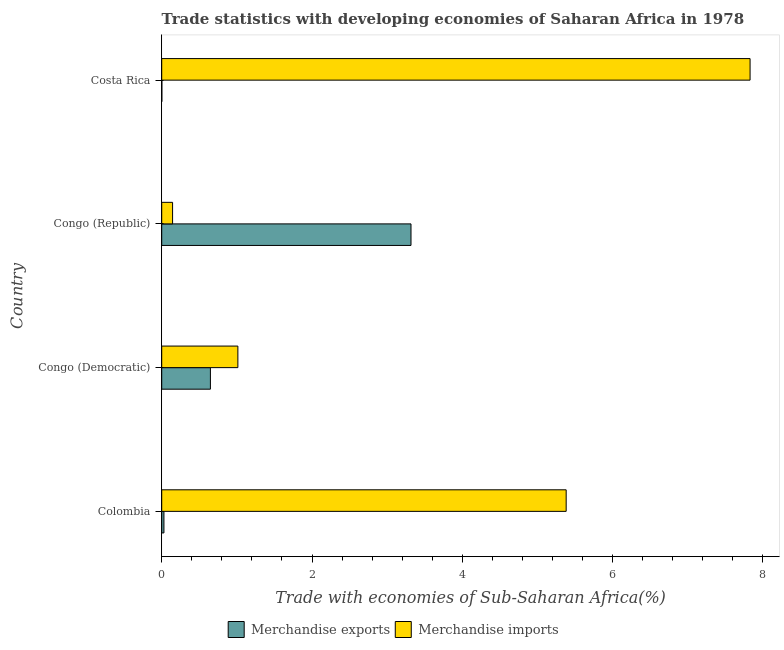How many different coloured bars are there?
Your response must be concise. 2. How many groups of bars are there?
Ensure brevity in your answer.  4. Are the number of bars per tick equal to the number of legend labels?
Your answer should be very brief. Yes. Are the number of bars on each tick of the Y-axis equal?
Keep it short and to the point. Yes. How many bars are there on the 2nd tick from the top?
Keep it short and to the point. 2. How many bars are there on the 4th tick from the bottom?
Your response must be concise. 2. What is the label of the 3rd group of bars from the top?
Give a very brief answer. Congo (Democratic). In how many cases, is the number of bars for a given country not equal to the number of legend labels?
Give a very brief answer. 0. What is the merchandise imports in Congo (Republic)?
Keep it short and to the point. 0.14. Across all countries, what is the maximum merchandise imports?
Keep it short and to the point. 7.83. Across all countries, what is the minimum merchandise imports?
Provide a succinct answer. 0.14. In which country was the merchandise exports maximum?
Keep it short and to the point. Congo (Republic). What is the total merchandise imports in the graph?
Offer a terse response. 14.37. What is the difference between the merchandise imports in Colombia and that in Costa Rica?
Provide a succinct answer. -2.45. What is the difference between the merchandise imports in Costa Rica and the merchandise exports in Congo (Republic)?
Your answer should be very brief. 4.51. What is the average merchandise imports per country?
Keep it short and to the point. 3.59. What is the difference between the merchandise imports and merchandise exports in Congo (Democratic)?
Provide a succinct answer. 0.37. In how many countries, is the merchandise exports greater than 2 %?
Provide a short and direct response. 1. What is the ratio of the merchandise exports in Congo (Democratic) to that in Congo (Republic)?
Offer a very short reply. 0.2. Is the merchandise exports in Congo (Democratic) less than that in Costa Rica?
Ensure brevity in your answer.  No. Is the difference between the merchandise exports in Congo (Democratic) and Congo (Republic) greater than the difference between the merchandise imports in Congo (Democratic) and Congo (Republic)?
Ensure brevity in your answer.  No. What is the difference between the highest and the second highest merchandise imports?
Your answer should be very brief. 2.45. What is the difference between the highest and the lowest merchandise exports?
Ensure brevity in your answer.  3.32. How many countries are there in the graph?
Give a very brief answer. 4. Are the values on the major ticks of X-axis written in scientific E-notation?
Your response must be concise. No. Where does the legend appear in the graph?
Offer a terse response. Bottom center. How many legend labels are there?
Keep it short and to the point. 2. How are the legend labels stacked?
Provide a short and direct response. Horizontal. What is the title of the graph?
Keep it short and to the point. Trade statistics with developing economies of Saharan Africa in 1978. Does "Non-residents" appear as one of the legend labels in the graph?
Your response must be concise. No. What is the label or title of the X-axis?
Ensure brevity in your answer.  Trade with economies of Sub-Saharan Africa(%). What is the label or title of the Y-axis?
Your response must be concise. Country. What is the Trade with economies of Sub-Saharan Africa(%) in Merchandise exports in Colombia?
Give a very brief answer. 0.03. What is the Trade with economies of Sub-Saharan Africa(%) of Merchandise imports in Colombia?
Make the answer very short. 5.38. What is the Trade with economies of Sub-Saharan Africa(%) of Merchandise exports in Congo (Democratic)?
Your answer should be very brief. 0.65. What is the Trade with economies of Sub-Saharan Africa(%) in Merchandise imports in Congo (Democratic)?
Provide a short and direct response. 1.01. What is the Trade with economies of Sub-Saharan Africa(%) of Merchandise exports in Congo (Republic)?
Provide a succinct answer. 3.32. What is the Trade with economies of Sub-Saharan Africa(%) of Merchandise imports in Congo (Republic)?
Make the answer very short. 0.14. What is the Trade with economies of Sub-Saharan Africa(%) of Merchandise exports in Costa Rica?
Provide a short and direct response. 0. What is the Trade with economies of Sub-Saharan Africa(%) in Merchandise imports in Costa Rica?
Give a very brief answer. 7.83. Across all countries, what is the maximum Trade with economies of Sub-Saharan Africa(%) in Merchandise exports?
Your answer should be very brief. 3.32. Across all countries, what is the maximum Trade with economies of Sub-Saharan Africa(%) of Merchandise imports?
Your response must be concise. 7.83. Across all countries, what is the minimum Trade with economies of Sub-Saharan Africa(%) of Merchandise exports?
Keep it short and to the point. 0. Across all countries, what is the minimum Trade with economies of Sub-Saharan Africa(%) of Merchandise imports?
Ensure brevity in your answer.  0.14. What is the total Trade with economies of Sub-Saharan Africa(%) of Merchandise exports in the graph?
Offer a very short reply. 4. What is the total Trade with economies of Sub-Saharan Africa(%) of Merchandise imports in the graph?
Your answer should be very brief. 14.37. What is the difference between the Trade with economies of Sub-Saharan Africa(%) of Merchandise exports in Colombia and that in Congo (Democratic)?
Keep it short and to the point. -0.62. What is the difference between the Trade with economies of Sub-Saharan Africa(%) of Merchandise imports in Colombia and that in Congo (Democratic)?
Offer a very short reply. 4.37. What is the difference between the Trade with economies of Sub-Saharan Africa(%) in Merchandise exports in Colombia and that in Congo (Republic)?
Your response must be concise. -3.29. What is the difference between the Trade with economies of Sub-Saharan Africa(%) of Merchandise imports in Colombia and that in Congo (Republic)?
Offer a terse response. 5.24. What is the difference between the Trade with economies of Sub-Saharan Africa(%) in Merchandise exports in Colombia and that in Costa Rica?
Ensure brevity in your answer.  0.03. What is the difference between the Trade with economies of Sub-Saharan Africa(%) of Merchandise imports in Colombia and that in Costa Rica?
Offer a very short reply. -2.45. What is the difference between the Trade with economies of Sub-Saharan Africa(%) of Merchandise exports in Congo (Democratic) and that in Congo (Republic)?
Provide a succinct answer. -2.67. What is the difference between the Trade with economies of Sub-Saharan Africa(%) in Merchandise imports in Congo (Democratic) and that in Congo (Republic)?
Provide a succinct answer. 0.87. What is the difference between the Trade with economies of Sub-Saharan Africa(%) in Merchandise exports in Congo (Democratic) and that in Costa Rica?
Keep it short and to the point. 0.65. What is the difference between the Trade with economies of Sub-Saharan Africa(%) in Merchandise imports in Congo (Democratic) and that in Costa Rica?
Keep it short and to the point. -6.82. What is the difference between the Trade with economies of Sub-Saharan Africa(%) in Merchandise exports in Congo (Republic) and that in Costa Rica?
Make the answer very short. 3.32. What is the difference between the Trade with economies of Sub-Saharan Africa(%) of Merchandise imports in Congo (Republic) and that in Costa Rica?
Make the answer very short. -7.68. What is the difference between the Trade with economies of Sub-Saharan Africa(%) of Merchandise exports in Colombia and the Trade with economies of Sub-Saharan Africa(%) of Merchandise imports in Congo (Democratic)?
Your response must be concise. -0.98. What is the difference between the Trade with economies of Sub-Saharan Africa(%) in Merchandise exports in Colombia and the Trade with economies of Sub-Saharan Africa(%) in Merchandise imports in Congo (Republic)?
Your answer should be very brief. -0.11. What is the difference between the Trade with economies of Sub-Saharan Africa(%) of Merchandise exports in Colombia and the Trade with economies of Sub-Saharan Africa(%) of Merchandise imports in Costa Rica?
Ensure brevity in your answer.  -7.8. What is the difference between the Trade with economies of Sub-Saharan Africa(%) in Merchandise exports in Congo (Democratic) and the Trade with economies of Sub-Saharan Africa(%) in Merchandise imports in Congo (Republic)?
Your response must be concise. 0.5. What is the difference between the Trade with economies of Sub-Saharan Africa(%) in Merchandise exports in Congo (Democratic) and the Trade with economies of Sub-Saharan Africa(%) in Merchandise imports in Costa Rica?
Make the answer very short. -7.18. What is the difference between the Trade with economies of Sub-Saharan Africa(%) of Merchandise exports in Congo (Republic) and the Trade with economies of Sub-Saharan Africa(%) of Merchandise imports in Costa Rica?
Ensure brevity in your answer.  -4.51. What is the average Trade with economies of Sub-Saharan Africa(%) of Merchandise exports per country?
Offer a terse response. 1. What is the average Trade with economies of Sub-Saharan Africa(%) in Merchandise imports per country?
Ensure brevity in your answer.  3.59. What is the difference between the Trade with economies of Sub-Saharan Africa(%) of Merchandise exports and Trade with economies of Sub-Saharan Africa(%) of Merchandise imports in Colombia?
Your response must be concise. -5.35. What is the difference between the Trade with economies of Sub-Saharan Africa(%) of Merchandise exports and Trade with economies of Sub-Saharan Africa(%) of Merchandise imports in Congo (Democratic)?
Offer a very short reply. -0.37. What is the difference between the Trade with economies of Sub-Saharan Africa(%) of Merchandise exports and Trade with economies of Sub-Saharan Africa(%) of Merchandise imports in Congo (Republic)?
Keep it short and to the point. 3.17. What is the difference between the Trade with economies of Sub-Saharan Africa(%) in Merchandise exports and Trade with economies of Sub-Saharan Africa(%) in Merchandise imports in Costa Rica?
Make the answer very short. -7.83. What is the ratio of the Trade with economies of Sub-Saharan Africa(%) in Merchandise exports in Colombia to that in Congo (Democratic)?
Provide a short and direct response. 0.05. What is the ratio of the Trade with economies of Sub-Saharan Africa(%) in Merchandise imports in Colombia to that in Congo (Democratic)?
Provide a succinct answer. 5.31. What is the ratio of the Trade with economies of Sub-Saharan Africa(%) in Merchandise exports in Colombia to that in Congo (Republic)?
Give a very brief answer. 0.01. What is the ratio of the Trade with economies of Sub-Saharan Africa(%) of Merchandise imports in Colombia to that in Congo (Republic)?
Keep it short and to the point. 37.23. What is the ratio of the Trade with economies of Sub-Saharan Africa(%) of Merchandise exports in Colombia to that in Costa Rica?
Make the answer very short. 16.08. What is the ratio of the Trade with economies of Sub-Saharan Africa(%) of Merchandise imports in Colombia to that in Costa Rica?
Provide a succinct answer. 0.69. What is the ratio of the Trade with economies of Sub-Saharan Africa(%) in Merchandise exports in Congo (Democratic) to that in Congo (Republic)?
Make the answer very short. 0.2. What is the ratio of the Trade with economies of Sub-Saharan Africa(%) of Merchandise imports in Congo (Democratic) to that in Congo (Republic)?
Give a very brief answer. 7.01. What is the ratio of the Trade with economies of Sub-Saharan Africa(%) of Merchandise exports in Congo (Democratic) to that in Costa Rica?
Your response must be concise. 351.77. What is the ratio of the Trade with economies of Sub-Saharan Africa(%) in Merchandise imports in Congo (Democratic) to that in Costa Rica?
Keep it short and to the point. 0.13. What is the ratio of the Trade with economies of Sub-Saharan Africa(%) of Merchandise exports in Congo (Republic) to that in Costa Rica?
Your answer should be compact. 1801.12. What is the ratio of the Trade with economies of Sub-Saharan Africa(%) in Merchandise imports in Congo (Republic) to that in Costa Rica?
Your answer should be compact. 0.02. What is the difference between the highest and the second highest Trade with economies of Sub-Saharan Africa(%) in Merchandise exports?
Your response must be concise. 2.67. What is the difference between the highest and the second highest Trade with economies of Sub-Saharan Africa(%) of Merchandise imports?
Your response must be concise. 2.45. What is the difference between the highest and the lowest Trade with economies of Sub-Saharan Africa(%) in Merchandise exports?
Offer a terse response. 3.32. What is the difference between the highest and the lowest Trade with economies of Sub-Saharan Africa(%) of Merchandise imports?
Ensure brevity in your answer.  7.68. 